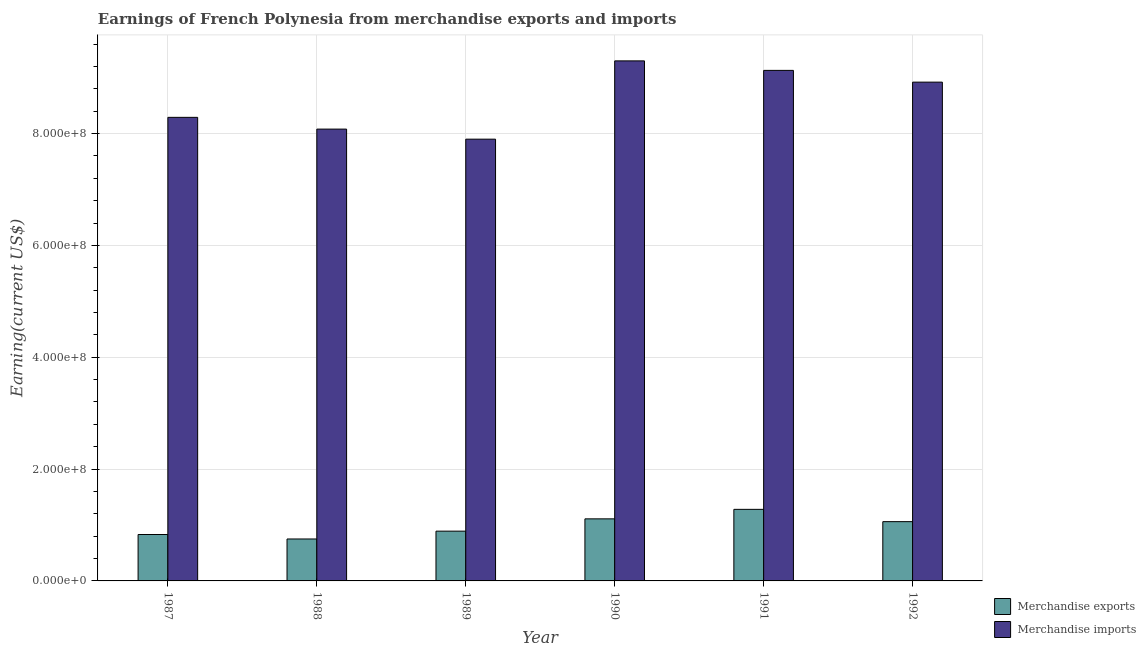How many groups of bars are there?
Offer a very short reply. 6. Are the number of bars on each tick of the X-axis equal?
Make the answer very short. Yes. How many bars are there on the 2nd tick from the left?
Provide a succinct answer. 2. In how many cases, is the number of bars for a given year not equal to the number of legend labels?
Make the answer very short. 0. What is the earnings from merchandise imports in 1992?
Provide a succinct answer. 8.92e+08. Across all years, what is the maximum earnings from merchandise imports?
Provide a succinct answer. 9.30e+08. Across all years, what is the minimum earnings from merchandise exports?
Provide a short and direct response. 7.50e+07. In which year was the earnings from merchandise exports minimum?
Ensure brevity in your answer.  1988. What is the total earnings from merchandise exports in the graph?
Provide a short and direct response. 5.92e+08. What is the difference between the earnings from merchandise exports in 1989 and that in 1992?
Provide a succinct answer. -1.70e+07. What is the difference between the earnings from merchandise exports in 1990 and the earnings from merchandise imports in 1992?
Offer a very short reply. 5.00e+06. What is the average earnings from merchandise imports per year?
Make the answer very short. 8.60e+08. In how many years, is the earnings from merchandise imports greater than 920000000 US$?
Ensure brevity in your answer.  1. What is the ratio of the earnings from merchandise imports in 1988 to that in 1991?
Provide a succinct answer. 0.88. Is the difference between the earnings from merchandise imports in 1987 and 1990 greater than the difference between the earnings from merchandise exports in 1987 and 1990?
Your answer should be compact. No. What is the difference between the highest and the second highest earnings from merchandise imports?
Provide a succinct answer. 1.70e+07. What is the difference between the highest and the lowest earnings from merchandise imports?
Provide a succinct answer. 1.40e+08. Is the sum of the earnings from merchandise imports in 1989 and 1992 greater than the maximum earnings from merchandise exports across all years?
Keep it short and to the point. Yes. What does the 2nd bar from the right in 1990 represents?
Offer a very short reply. Merchandise exports. How many bars are there?
Provide a short and direct response. 12. Are all the bars in the graph horizontal?
Keep it short and to the point. No. What is the difference between two consecutive major ticks on the Y-axis?
Your answer should be very brief. 2.00e+08. Are the values on the major ticks of Y-axis written in scientific E-notation?
Give a very brief answer. Yes. Where does the legend appear in the graph?
Provide a succinct answer. Bottom right. What is the title of the graph?
Offer a very short reply. Earnings of French Polynesia from merchandise exports and imports. Does "Resident" appear as one of the legend labels in the graph?
Make the answer very short. No. What is the label or title of the X-axis?
Offer a terse response. Year. What is the label or title of the Y-axis?
Provide a short and direct response. Earning(current US$). What is the Earning(current US$) of Merchandise exports in 1987?
Offer a terse response. 8.30e+07. What is the Earning(current US$) in Merchandise imports in 1987?
Offer a terse response. 8.29e+08. What is the Earning(current US$) of Merchandise exports in 1988?
Your answer should be compact. 7.50e+07. What is the Earning(current US$) in Merchandise imports in 1988?
Give a very brief answer. 8.08e+08. What is the Earning(current US$) of Merchandise exports in 1989?
Keep it short and to the point. 8.90e+07. What is the Earning(current US$) of Merchandise imports in 1989?
Provide a short and direct response. 7.90e+08. What is the Earning(current US$) in Merchandise exports in 1990?
Offer a terse response. 1.11e+08. What is the Earning(current US$) of Merchandise imports in 1990?
Offer a terse response. 9.30e+08. What is the Earning(current US$) in Merchandise exports in 1991?
Provide a succinct answer. 1.28e+08. What is the Earning(current US$) of Merchandise imports in 1991?
Offer a terse response. 9.13e+08. What is the Earning(current US$) of Merchandise exports in 1992?
Your answer should be very brief. 1.06e+08. What is the Earning(current US$) of Merchandise imports in 1992?
Your answer should be very brief. 8.92e+08. Across all years, what is the maximum Earning(current US$) of Merchandise exports?
Keep it short and to the point. 1.28e+08. Across all years, what is the maximum Earning(current US$) of Merchandise imports?
Offer a terse response. 9.30e+08. Across all years, what is the minimum Earning(current US$) in Merchandise exports?
Provide a short and direct response. 7.50e+07. Across all years, what is the minimum Earning(current US$) in Merchandise imports?
Ensure brevity in your answer.  7.90e+08. What is the total Earning(current US$) in Merchandise exports in the graph?
Make the answer very short. 5.92e+08. What is the total Earning(current US$) of Merchandise imports in the graph?
Your answer should be very brief. 5.16e+09. What is the difference between the Earning(current US$) of Merchandise imports in 1987 and that in 1988?
Your answer should be compact. 2.10e+07. What is the difference between the Earning(current US$) in Merchandise exports in 1987 and that in 1989?
Ensure brevity in your answer.  -6.00e+06. What is the difference between the Earning(current US$) in Merchandise imports in 1987 and that in 1989?
Offer a terse response. 3.90e+07. What is the difference between the Earning(current US$) in Merchandise exports in 1987 and that in 1990?
Your answer should be very brief. -2.80e+07. What is the difference between the Earning(current US$) of Merchandise imports in 1987 and that in 1990?
Provide a short and direct response. -1.01e+08. What is the difference between the Earning(current US$) in Merchandise exports in 1987 and that in 1991?
Your answer should be compact. -4.50e+07. What is the difference between the Earning(current US$) of Merchandise imports in 1987 and that in 1991?
Offer a terse response. -8.40e+07. What is the difference between the Earning(current US$) in Merchandise exports in 1987 and that in 1992?
Ensure brevity in your answer.  -2.30e+07. What is the difference between the Earning(current US$) of Merchandise imports in 1987 and that in 1992?
Keep it short and to the point. -6.30e+07. What is the difference between the Earning(current US$) in Merchandise exports in 1988 and that in 1989?
Provide a succinct answer. -1.40e+07. What is the difference between the Earning(current US$) of Merchandise imports in 1988 and that in 1989?
Keep it short and to the point. 1.80e+07. What is the difference between the Earning(current US$) of Merchandise exports in 1988 and that in 1990?
Provide a succinct answer. -3.60e+07. What is the difference between the Earning(current US$) in Merchandise imports in 1988 and that in 1990?
Your answer should be compact. -1.22e+08. What is the difference between the Earning(current US$) of Merchandise exports in 1988 and that in 1991?
Your answer should be very brief. -5.30e+07. What is the difference between the Earning(current US$) in Merchandise imports in 1988 and that in 1991?
Your answer should be compact. -1.05e+08. What is the difference between the Earning(current US$) of Merchandise exports in 1988 and that in 1992?
Offer a very short reply. -3.10e+07. What is the difference between the Earning(current US$) of Merchandise imports in 1988 and that in 1992?
Keep it short and to the point. -8.40e+07. What is the difference between the Earning(current US$) of Merchandise exports in 1989 and that in 1990?
Provide a short and direct response. -2.20e+07. What is the difference between the Earning(current US$) in Merchandise imports in 1989 and that in 1990?
Keep it short and to the point. -1.40e+08. What is the difference between the Earning(current US$) in Merchandise exports in 1989 and that in 1991?
Keep it short and to the point. -3.90e+07. What is the difference between the Earning(current US$) of Merchandise imports in 1989 and that in 1991?
Ensure brevity in your answer.  -1.23e+08. What is the difference between the Earning(current US$) of Merchandise exports in 1989 and that in 1992?
Keep it short and to the point. -1.70e+07. What is the difference between the Earning(current US$) in Merchandise imports in 1989 and that in 1992?
Ensure brevity in your answer.  -1.02e+08. What is the difference between the Earning(current US$) of Merchandise exports in 1990 and that in 1991?
Your response must be concise. -1.70e+07. What is the difference between the Earning(current US$) in Merchandise imports in 1990 and that in 1991?
Offer a terse response. 1.70e+07. What is the difference between the Earning(current US$) of Merchandise imports in 1990 and that in 1992?
Give a very brief answer. 3.80e+07. What is the difference between the Earning(current US$) of Merchandise exports in 1991 and that in 1992?
Provide a succinct answer. 2.20e+07. What is the difference between the Earning(current US$) of Merchandise imports in 1991 and that in 1992?
Give a very brief answer. 2.10e+07. What is the difference between the Earning(current US$) in Merchandise exports in 1987 and the Earning(current US$) in Merchandise imports in 1988?
Your response must be concise. -7.25e+08. What is the difference between the Earning(current US$) of Merchandise exports in 1987 and the Earning(current US$) of Merchandise imports in 1989?
Your answer should be very brief. -7.07e+08. What is the difference between the Earning(current US$) in Merchandise exports in 1987 and the Earning(current US$) in Merchandise imports in 1990?
Provide a succinct answer. -8.47e+08. What is the difference between the Earning(current US$) in Merchandise exports in 1987 and the Earning(current US$) in Merchandise imports in 1991?
Offer a very short reply. -8.30e+08. What is the difference between the Earning(current US$) in Merchandise exports in 1987 and the Earning(current US$) in Merchandise imports in 1992?
Provide a succinct answer. -8.09e+08. What is the difference between the Earning(current US$) in Merchandise exports in 1988 and the Earning(current US$) in Merchandise imports in 1989?
Provide a succinct answer. -7.15e+08. What is the difference between the Earning(current US$) of Merchandise exports in 1988 and the Earning(current US$) of Merchandise imports in 1990?
Provide a short and direct response. -8.55e+08. What is the difference between the Earning(current US$) of Merchandise exports in 1988 and the Earning(current US$) of Merchandise imports in 1991?
Ensure brevity in your answer.  -8.38e+08. What is the difference between the Earning(current US$) in Merchandise exports in 1988 and the Earning(current US$) in Merchandise imports in 1992?
Ensure brevity in your answer.  -8.17e+08. What is the difference between the Earning(current US$) in Merchandise exports in 1989 and the Earning(current US$) in Merchandise imports in 1990?
Make the answer very short. -8.41e+08. What is the difference between the Earning(current US$) in Merchandise exports in 1989 and the Earning(current US$) in Merchandise imports in 1991?
Ensure brevity in your answer.  -8.24e+08. What is the difference between the Earning(current US$) of Merchandise exports in 1989 and the Earning(current US$) of Merchandise imports in 1992?
Make the answer very short. -8.03e+08. What is the difference between the Earning(current US$) of Merchandise exports in 1990 and the Earning(current US$) of Merchandise imports in 1991?
Offer a very short reply. -8.02e+08. What is the difference between the Earning(current US$) in Merchandise exports in 1990 and the Earning(current US$) in Merchandise imports in 1992?
Provide a succinct answer. -7.81e+08. What is the difference between the Earning(current US$) in Merchandise exports in 1991 and the Earning(current US$) in Merchandise imports in 1992?
Your answer should be compact. -7.64e+08. What is the average Earning(current US$) in Merchandise exports per year?
Provide a short and direct response. 9.87e+07. What is the average Earning(current US$) in Merchandise imports per year?
Make the answer very short. 8.60e+08. In the year 1987, what is the difference between the Earning(current US$) in Merchandise exports and Earning(current US$) in Merchandise imports?
Your answer should be very brief. -7.46e+08. In the year 1988, what is the difference between the Earning(current US$) in Merchandise exports and Earning(current US$) in Merchandise imports?
Your answer should be compact. -7.33e+08. In the year 1989, what is the difference between the Earning(current US$) in Merchandise exports and Earning(current US$) in Merchandise imports?
Offer a very short reply. -7.01e+08. In the year 1990, what is the difference between the Earning(current US$) of Merchandise exports and Earning(current US$) of Merchandise imports?
Provide a succinct answer. -8.19e+08. In the year 1991, what is the difference between the Earning(current US$) in Merchandise exports and Earning(current US$) in Merchandise imports?
Provide a succinct answer. -7.85e+08. In the year 1992, what is the difference between the Earning(current US$) of Merchandise exports and Earning(current US$) of Merchandise imports?
Offer a very short reply. -7.86e+08. What is the ratio of the Earning(current US$) of Merchandise exports in 1987 to that in 1988?
Offer a very short reply. 1.11. What is the ratio of the Earning(current US$) in Merchandise exports in 1987 to that in 1989?
Provide a short and direct response. 0.93. What is the ratio of the Earning(current US$) in Merchandise imports in 1987 to that in 1989?
Make the answer very short. 1.05. What is the ratio of the Earning(current US$) in Merchandise exports in 1987 to that in 1990?
Provide a short and direct response. 0.75. What is the ratio of the Earning(current US$) in Merchandise imports in 1987 to that in 1990?
Provide a succinct answer. 0.89. What is the ratio of the Earning(current US$) of Merchandise exports in 1987 to that in 1991?
Your answer should be compact. 0.65. What is the ratio of the Earning(current US$) of Merchandise imports in 1987 to that in 1991?
Give a very brief answer. 0.91. What is the ratio of the Earning(current US$) of Merchandise exports in 1987 to that in 1992?
Ensure brevity in your answer.  0.78. What is the ratio of the Earning(current US$) of Merchandise imports in 1987 to that in 1992?
Offer a very short reply. 0.93. What is the ratio of the Earning(current US$) of Merchandise exports in 1988 to that in 1989?
Your response must be concise. 0.84. What is the ratio of the Earning(current US$) in Merchandise imports in 1988 to that in 1989?
Your response must be concise. 1.02. What is the ratio of the Earning(current US$) in Merchandise exports in 1988 to that in 1990?
Provide a succinct answer. 0.68. What is the ratio of the Earning(current US$) in Merchandise imports in 1988 to that in 1990?
Offer a terse response. 0.87. What is the ratio of the Earning(current US$) in Merchandise exports in 1988 to that in 1991?
Your answer should be compact. 0.59. What is the ratio of the Earning(current US$) in Merchandise imports in 1988 to that in 1991?
Ensure brevity in your answer.  0.89. What is the ratio of the Earning(current US$) in Merchandise exports in 1988 to that in 1992?
Provide a succinct answer. 0.71. What is the ratio of the Earning(current US$) in Merchandise imports in 1988 to that in 1992?
Provide a short and direct response. 0.91. What is the ratio of the Earning(current US$) in Merchandise exports in 1989 to that in 1990?
Provide a short and direct response. 0.8. What is the ratio of the Earning(current US$) of Merchandise imports in 1989 to that in 1990?
Offer a very short reply. 0.85. What is the ratio of the Earning(current US$) in Merchandise exports in 1989 to that in 1991?
Keep it short and to the point. 0.7. What is the ratio of the Earning(current US$) in Merchandise imports in 1989 to that in 1991?
Your answer should be compact. 0.87. What is the ratio of the Earning(current US$) of Merchandise exports in 1989 to that in 1992?
Offer a terse response. 0.84. What is the ratio of the Earning(current US$) in Merchandise imports in 1989 to that in 1992?
Your answer should be compact. 0.89. What is the ratio of the Earning(current US$) of Merchandise exports in 1990 to that in 1991?
Your answer should be compact. 0.87. What is the ratio of the Earning(current US$) of Merchandise imports in 1990 to that in 1991?
Make the answer very short. 1.02. What is the ratio of the Earning(current US$) of Merchandise exports in 1990 to that in 1992?
Your answer should be compact. 1.05. What is the ratio of the Earning(current US$) in Merchandise imports in 1990 to that in 1992?
Your response must be concise. 1.04. What is the ratio of the Earning(current US$) in Merchandise exports in 1991 to that in 1992?
Your answer should be very brief. 1.21. What is the ratio of the Earning(current US$) in Merchandise imports in 1991 to that in 1992?
Keep it short and to the point. 1.02. What is the difference between the highest and the second highest Earning(current US$) of Merchandise exports?
Provide a succinct answer. 1.70e+07. What is the difference between the highest and the second highest Earning(current US$) in Merchandise imports?
Provide a succinct answer. 1.70e+07. What is the difference between the highest and the lowest Earning(current US$) of Merchandise exports?
Your response must be concise. 5.30e+07. What is the difference between the highest and the lowest Earning(current US$) in Merchandise imports?
Provide a succinct answer. 1.40e+08. 